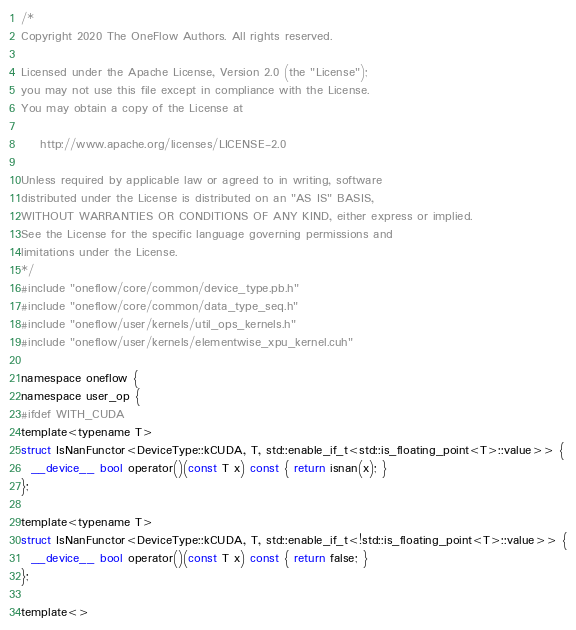<code> <loc_0><loc_0><loc_500><loc_500><_Cuda_>/*
Copyright 2020 The OneFlow Authors. All rights reserved.

Licensed under the Apache License, Version 2.0 (the "License");
you may not use this file except in compliance with the License.
You may obtain a copy of the License at

    http://www.apache.org/licenses/LICENSE-2.0

Unless required by applicable law or agreed to in writing, software
distributed under the License is distributed on an "AS IS" BASIS,
WITHOUT WARRANTIES OR CONDITIONS OF ANY KIND, either express or implied.
See the License for the specific language governing permissions and
limitations under the License.
*/
#include "oneflow/core/common/device_type.pb.h"
#include "oneflow/core/common/data_type_seq.h"
#include "oneflow/user/kernels/util_ops_kernels.h"
#include "oneflow/user/kernels/elementwise_xpu_kernel.cuh"

namespace oneflow {
namespace user_op {
#ifdef WITH_CUDA
template<typename T>
struct IsNanFunctor<DeviceType::kCUDA, T, std::enable_if_t<std::is_floating_point<T>::value>> {
  __device__ bool operator()(const T x) const { return isnan(x); }
};

template<typename T>
struct IsNanFunctor<DeviceType::kCUDA, T, std::enable_if_t<!std::is_floating_point<T>::value>> {
  __device__ bool operator()(const T x) const { return false; }
};

template<></code> 